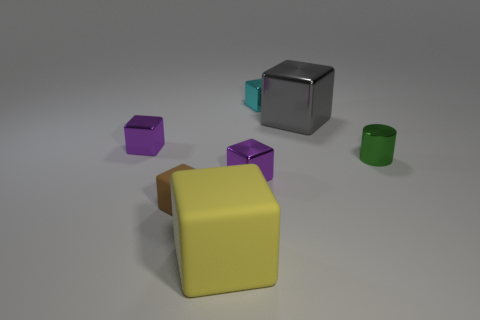Subtract all shiny blocks. How many blocks are left? 2 Subtract all brown cubes. How many cubes are left? 5 Subtract 1 blocks. How many blocks are left? 5 Add 1 small brown objects. How many objects exist? 8 Subtract all blue cubes. Subtract all gray balls. How many cubes are left? 6 Subtract all cubes. How many objects are left? 1 Add 1 big blocks. How many big blocks are left? 3 Add 5 small metal cylinders. How many small metal cylinders exist? 6 Subtract 1 cyan blocks. How many objects are left? 6 Subtract all large yellow cubes. Subtract all big gray blocks. How many objects are left? 5 